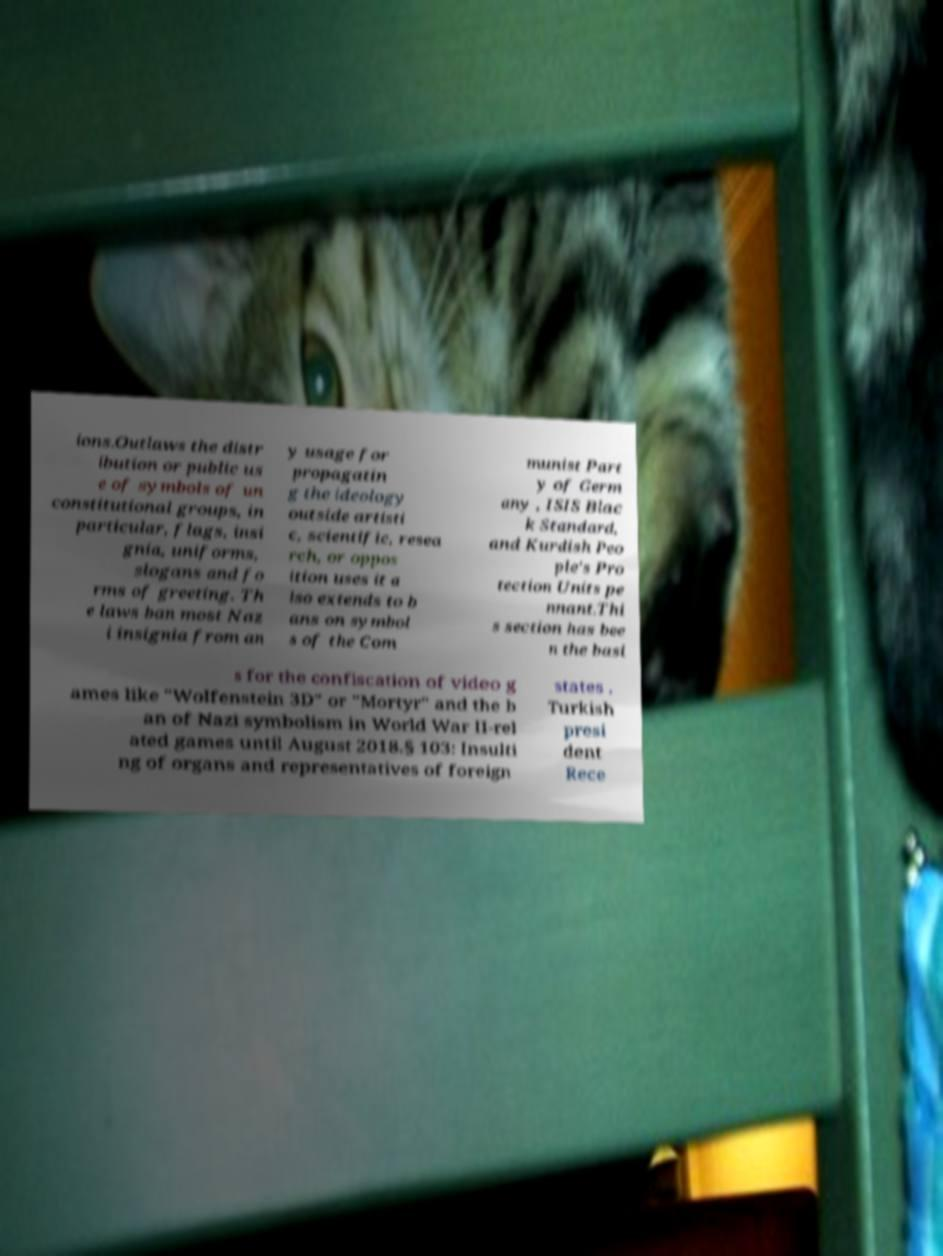Can you read and provide the text displayed in the image?This photo seems to have some interesting text. Can you extract and type it out for me? ions.Outlaws the distr ibution or public us e of symbols of un constitutional groups, in particular, flags, insi gnia, uniforms, slogans and fo rms of greeting. Th e laws ban most Naz i insignia from an y usage for propagatin g the ideology outside artisti c, scientific, resea rch, or oppos ition uses it a lso extends to b ans on symbol s of the Com munist Part y of Germ any , ISIS Blac k Standard, and Kurdish Peo ple's Pro tection Units pe nnant.Thi s section has bee n the basi s for the confiscation of video g ames like "Wolfenstein 3D" or "Mortyr" and the b an of Nazi symbolism in World War II-rel ated games until August 2018.§ 103: Insulti ng of organs and representatives of foreign states . Turkish presi dent Rece 